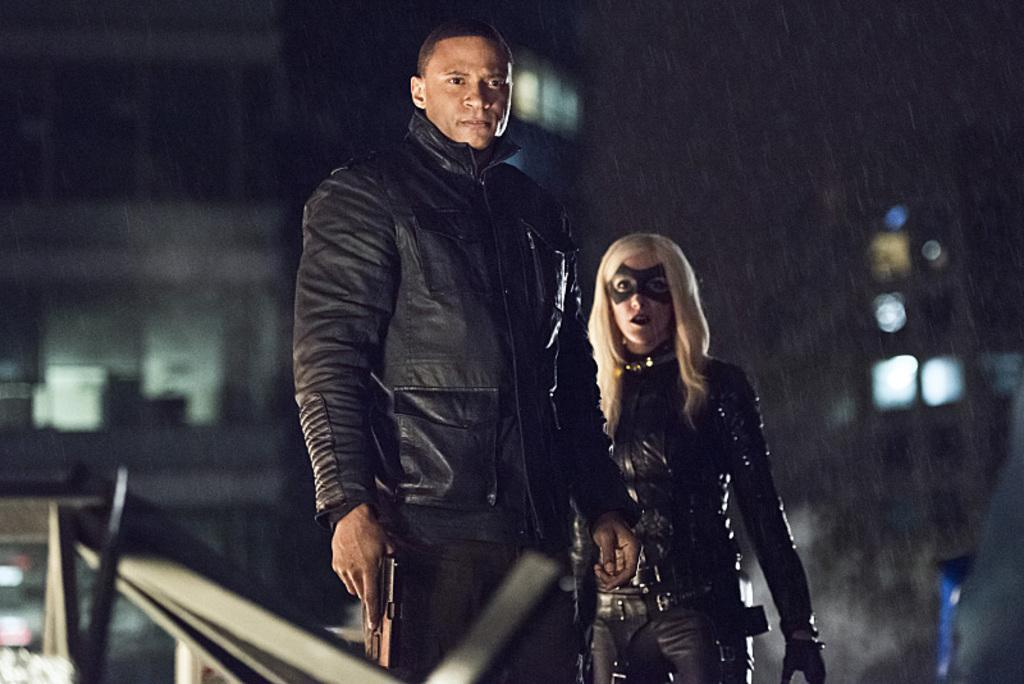How many people are in the image? There are people in the image, but the exact number is not specified. What is one person doing in the image? One person is holding a gun in the image. Can you describe the background of the image? The background of the image is blurred, and there are lights visible in it. What can be seen on the left side of the image? There are objects on the left side of the image. What type of truck is being used for the feast in the image? There is no truck or feast present in the image. How does the gun contribute to the death depicted in the image? There is no death depicted in the image; it only shows a person holding a gun. 